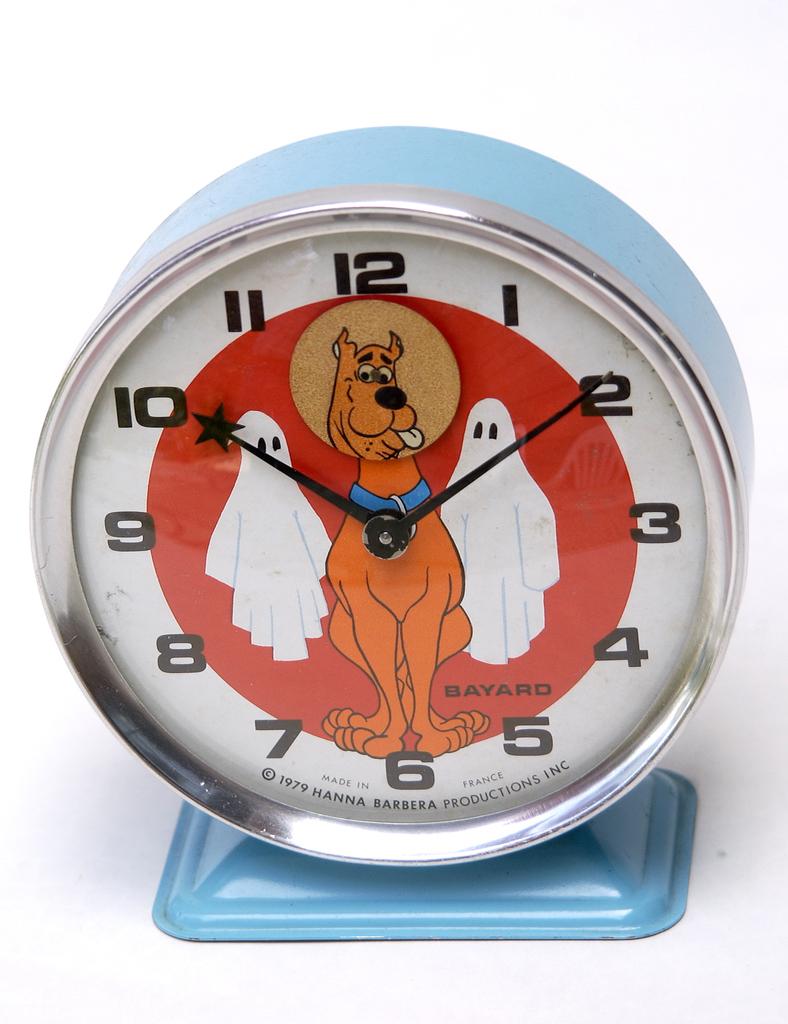What is the brand of the clock?
Offer a very short reply. Bayard. What is the copyright date at the bottom of the clock?
Offer a terse response. 1979. 